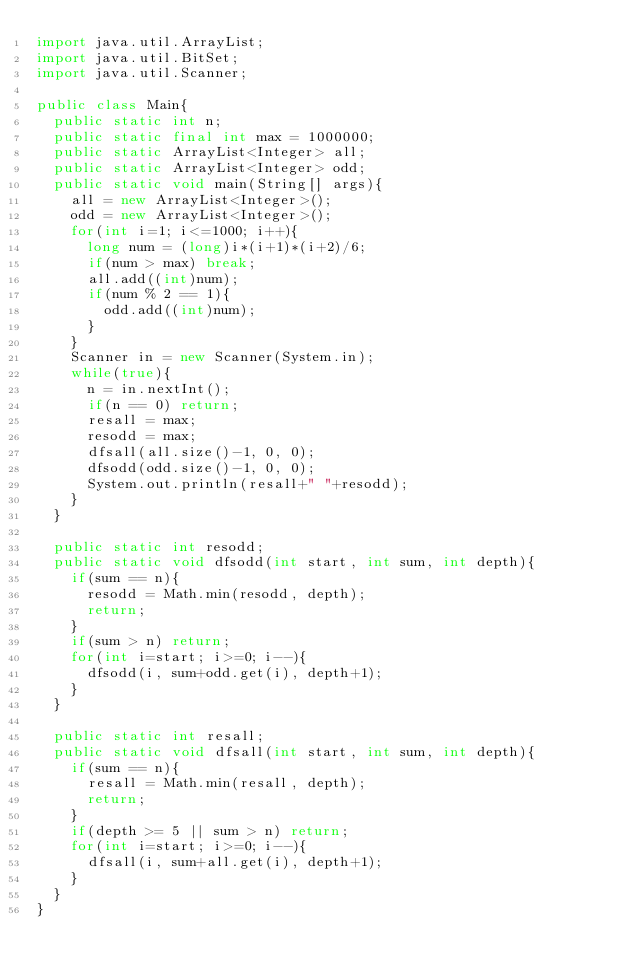<code> <loc_0><loc_0><loc_500><loc_500><_Java_>import java.util.ArrayList;
import java.util.BitSet;
import java.util.Scanner;

public class Main{
	public static int n;
	public static final int max = 1000000;
	public static ArrayList<Integer> all;
	public static ArrayList<Integer> odd;
	public static void main(String[] args){
		all = new ArrayList<Integer>();
		odd = new ArrayList<Integer>();
		for(int i=1; i<=1000; i++){
			long num = (long)i*(i+1)*(i+2)/6;
			if(num > max) break;
			all.add((int)num);
			if(num % 2 == 1){
				odd.add((int)num);
			}
		}
		Scanner in = new Scanner(System.in);
		while(true){
			n = in.nextInt();
			if(n == 0) return;
			resall = max;
			resodd = max;
			dfsall(all.size()-1, 0, 0);
			dfsodd(odd.size()-1, 0, 0);
			System.out.println(resall+" "+resodd);
		}
	}
	
	public static int resodd;
	public static void dfsodd(int start, int sum, int depth){
		if(sum == n){
			resodd = Math.min(resodd, depth);
			return;
		}
		if(sum > n) return;
		for(int i=start; i>=0; i--){
			dfsodd(i, sum+odd.get(i), depth+1);
		}
	}
	
	public static int resall;
	public static void dfsall(int start, int sum, int depth){
		if(sum == n){
			resall = Math.min(resall, depth);
			return;
		}
		if(depth >= 5 || sum > n) return;
		for(int i=start; i>=0; i--){
			dfsall(i, sum+all.get(i), depth+1);
		}
	}
}</code> 